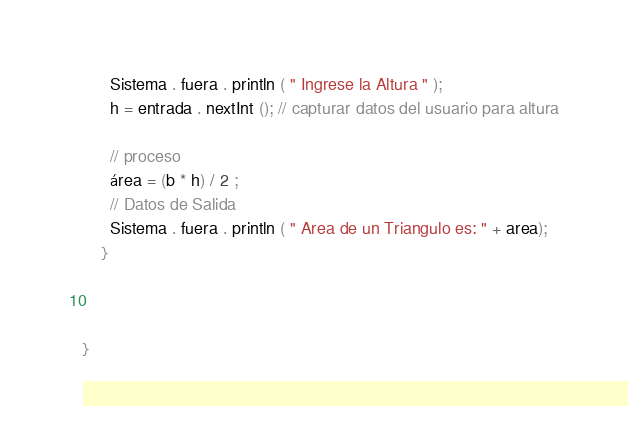<code> <loc_0><loc_0><loc_500><loc_500><_Java_>      Sistema . fuera . println ( " Ingrese la Altura " );
      h = entrada . nextInt (); // capturar datos del usuario para altura
      
      // proceso
      área = (b * h) / 2 ;
      // Datos de Salida
      Sistema . fuera . println ( " Area de un Triangulo es: " + area);
    }



}</code> 